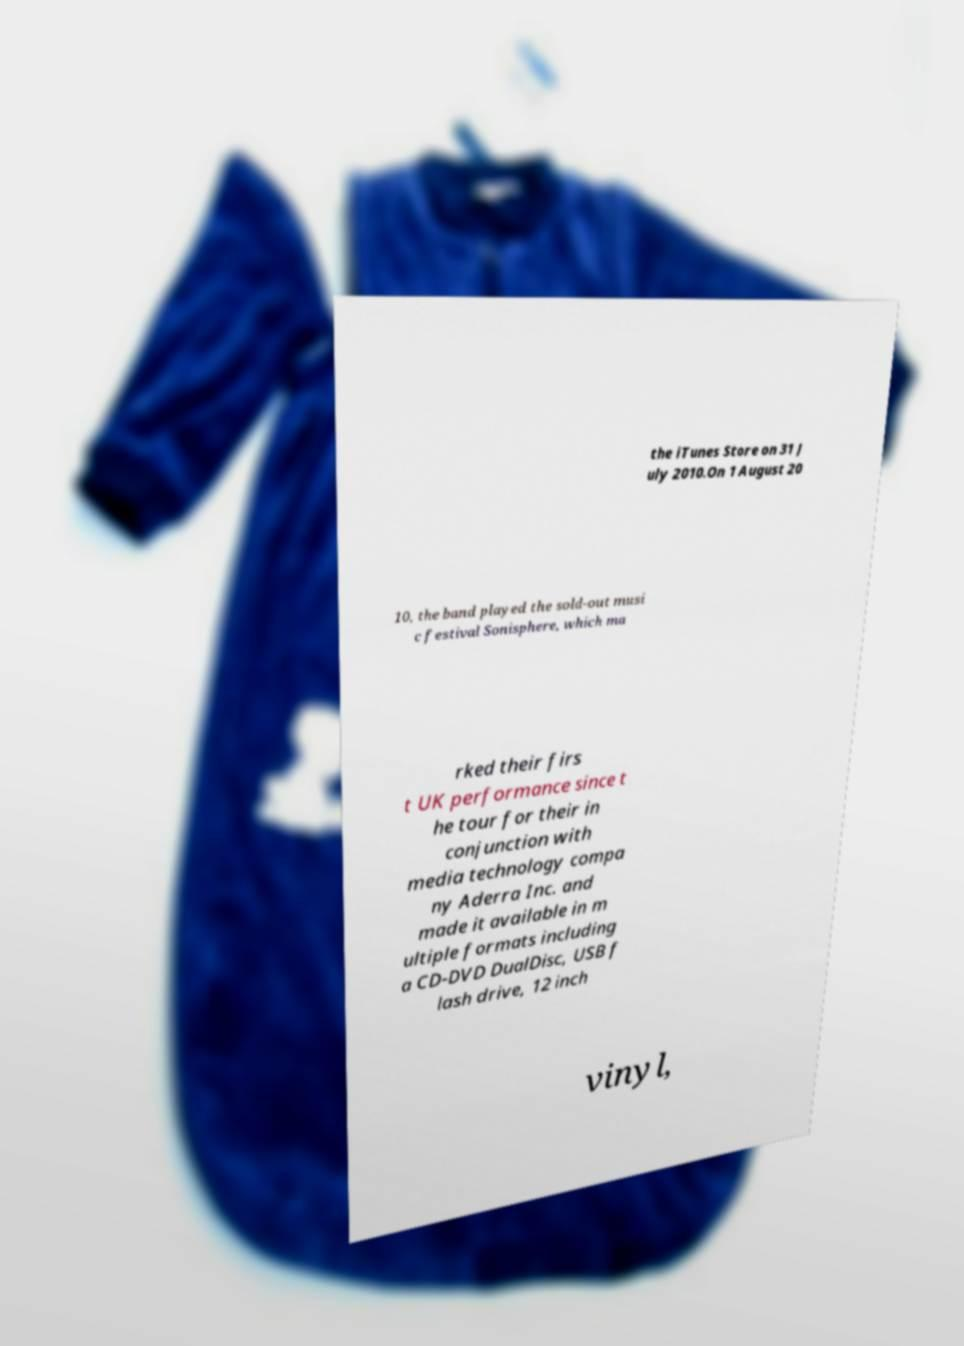For documentation purposes, I need the text within this image transcribed. Could you provide that? the iTunes Store on 31 J uly 2010.On 1 August 20 10, the band played the sold-out musi c festival Sonisphere, which ma rked their firs t UK performance since t he tour for their in conjunction with media technology compa ny Aderra Inc. and made it available in m ultiple formats including a CD-DVD DualDisc, USB f lash drive, 12 inch vinyl, 